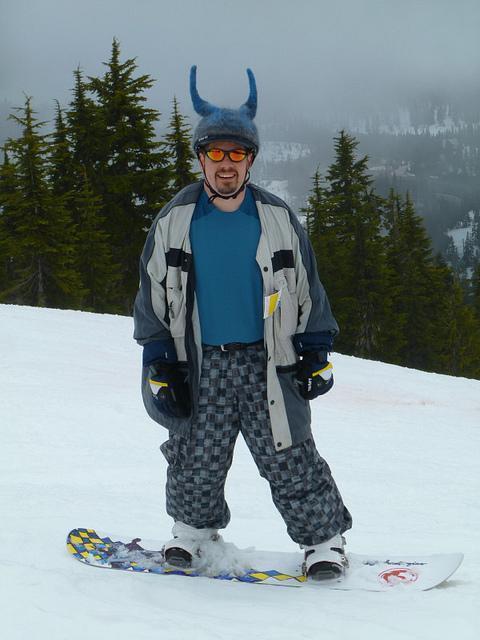How many people can you see?
Give a very brief answer. 1. 